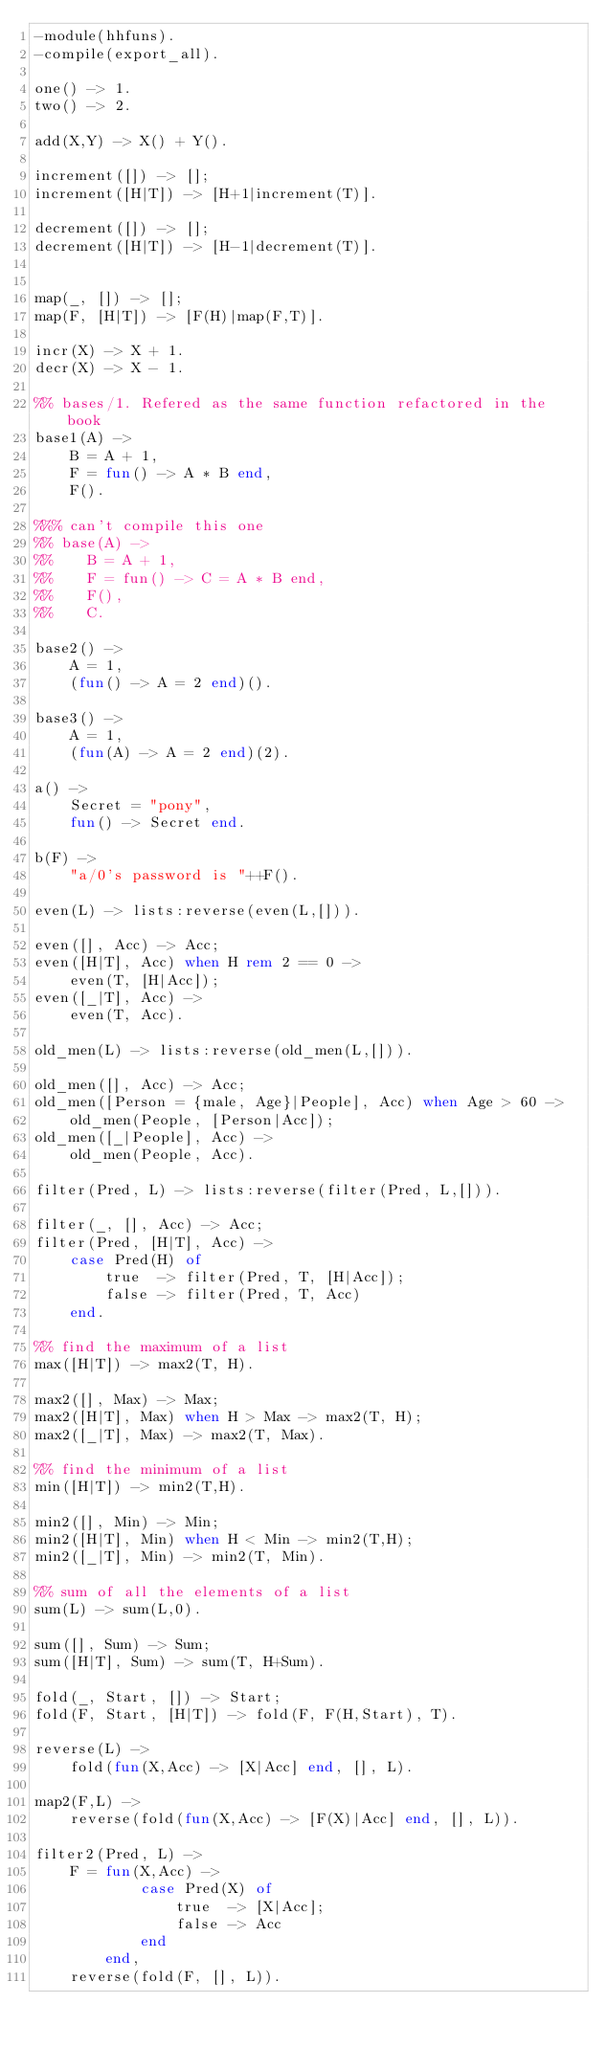<code> <loc_0><loc_0><loc_500><loc_500><_Erlang_>-module(hhfuns).
-compile(export_all).

one() -> 1.
two() -> 2.

add(X,Y) -> X() + Y().

increment([]) -> [];
increment([H|T]) -> [H+1|increment(T)].

decrement([]) -> [];
decrement([H|T]) -> [H-1|decrement(T)].


map(_, []) -> [];
map(F, [H|T]) -> [F(H)|map(F,T)].

incr(X) -> X + 1.
decr(X) -> X - 1.

%% bases/1. Refered as the same function refactored in the book
base1(A) ->
    B = A + 1,
    F = fun() -> A * B end,
    F().

%%% can't compile this one
%% base(A) ->
%%    B = A + 1,
%%    F = fun() -> C = A * B end,
%%    F(),
%%    C.

base2() ->
    A = 1,
    (fun() -> A = 2 end)().

base3() ->
    A = 1,
    (fun(A) -> A = 2 end)(2).

a() ->
    Secret = "pony",
    fun() -> Secret end.

b(F) ->
    "a/0's password is "++F().

even(L) -> lists:reverse(even(L,[])).

even([], Acc) -> Acc;
even([H|T], Acc) when H rem 2 == 0 ->
    even(T, [H|Acc]);
even([_|T], Acc) ->
    even(T, Acc).

old_men(L) -> lists:reverse(old_men(L,[])).

old_men([], Acc) -> Acc;
old_men([Person = {male, Age}|People], Acc) when Age > 60 ->
    old_men(People, [Person|Acc]);
old_men([_|People], Acc) ->
    old_men(People, Acc).

filter(Pred, L) -> lists:reverse(filter(Pred, L,[])).

filter(_, [], Acc) -> Acc;
filter(Pred, [H|T], Acc) ->
    case Pred(H) of
        true  -> filter(Pred, T, [H|Acc]);
        false -> filter(Pred, T, Acc)
    end.

%% find the maximum of a list
max([H|T]) -> max2(T, H).

max2([], Max) -> Max;
max2([H|T], Max) when H > Max -> max2(T, H);
max2([_|T], Max) -> max2(T, Max).

%% find the minimum of a list
min([H|T]) -> min2(T,H).

min2([], Min) -> Min;
min2([H|T], Min) when H < Min -> min2(T,H);
min2([_|T], Min) -> min2(T, Min).

%% sum of all the elements of a list
sum(L) -> sum(L,0).

sum([], Sum) -> Sum;
sum([H|T], Sum) -> sum(T, H+Sum).

fold(_, Start, []) -> Start;
fold(F, Start, [H|T]) -> fold(F, F(H,Start), T).

reverse(L) ->
    fold(fun(X,Acc) -> [X|Acc] end, [], L).

map2(F,L) ->
    reverse(fold(fun(X,Acc) -> [F(X)|Acc] end, [], L)).

filter2(Pred, L) ->
    F = fun(X,Acc) ->
            case Pred(X) of
                true  -> [X|Acc];
                false -> Acc
            end
        end,
    reverse(fold(F, [], L)).
</code> 